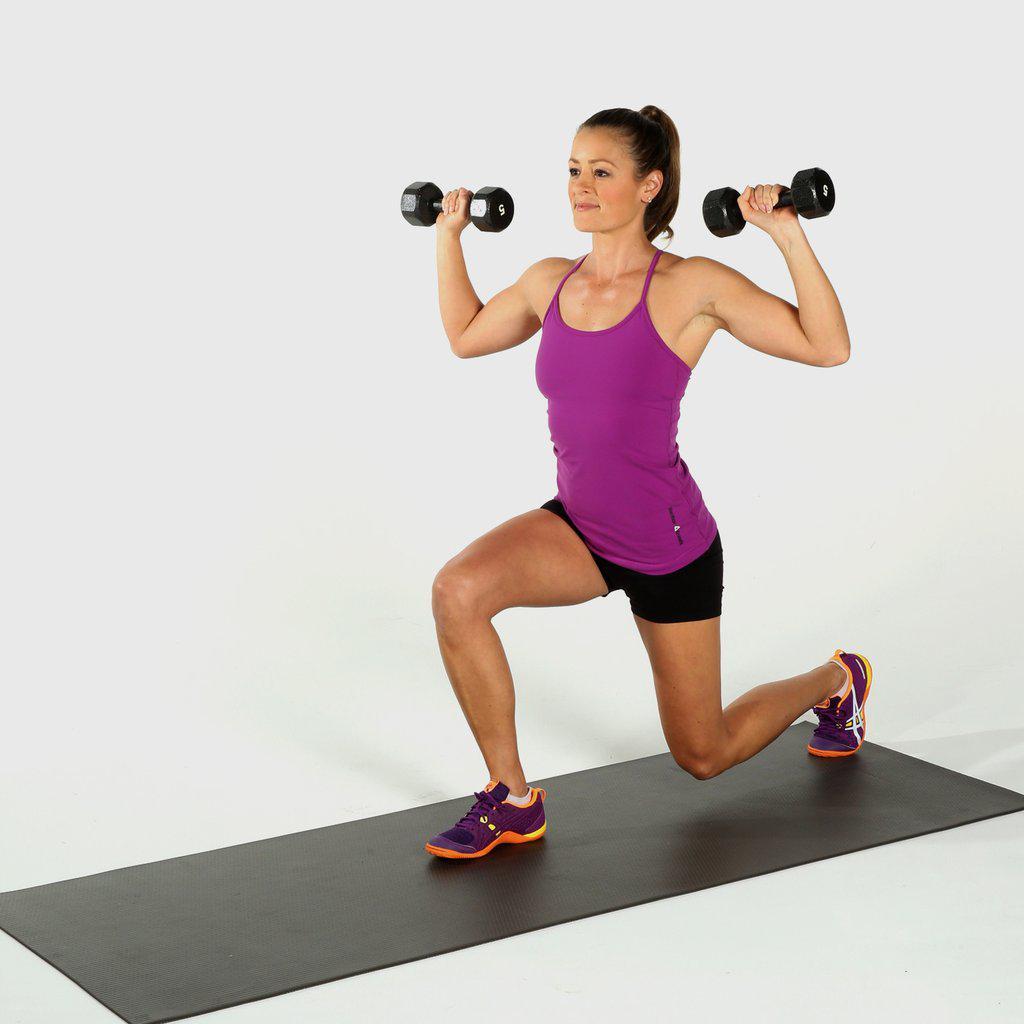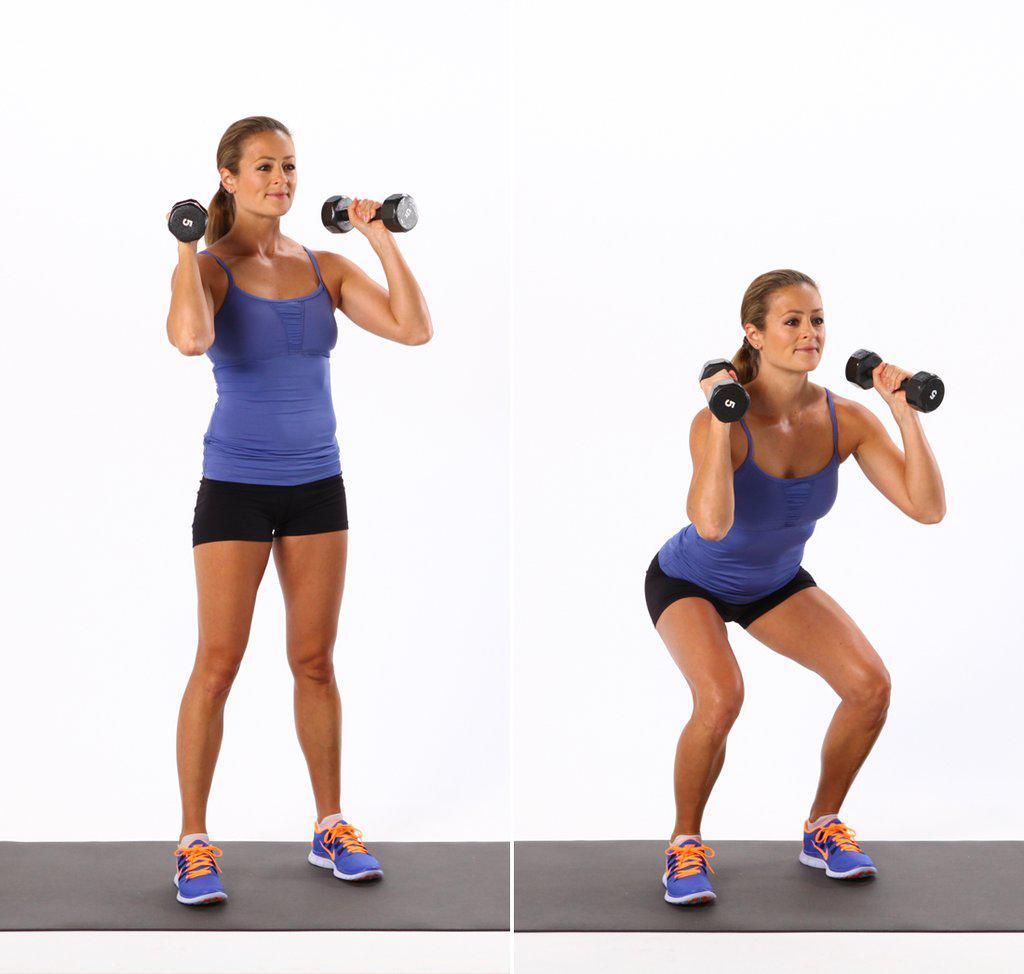The first image is the image on the left, the second image is the image on the right. Given the left and right images, does the statement "There are more people in the image on the right." hold true? Answer yes or no. Yes. 